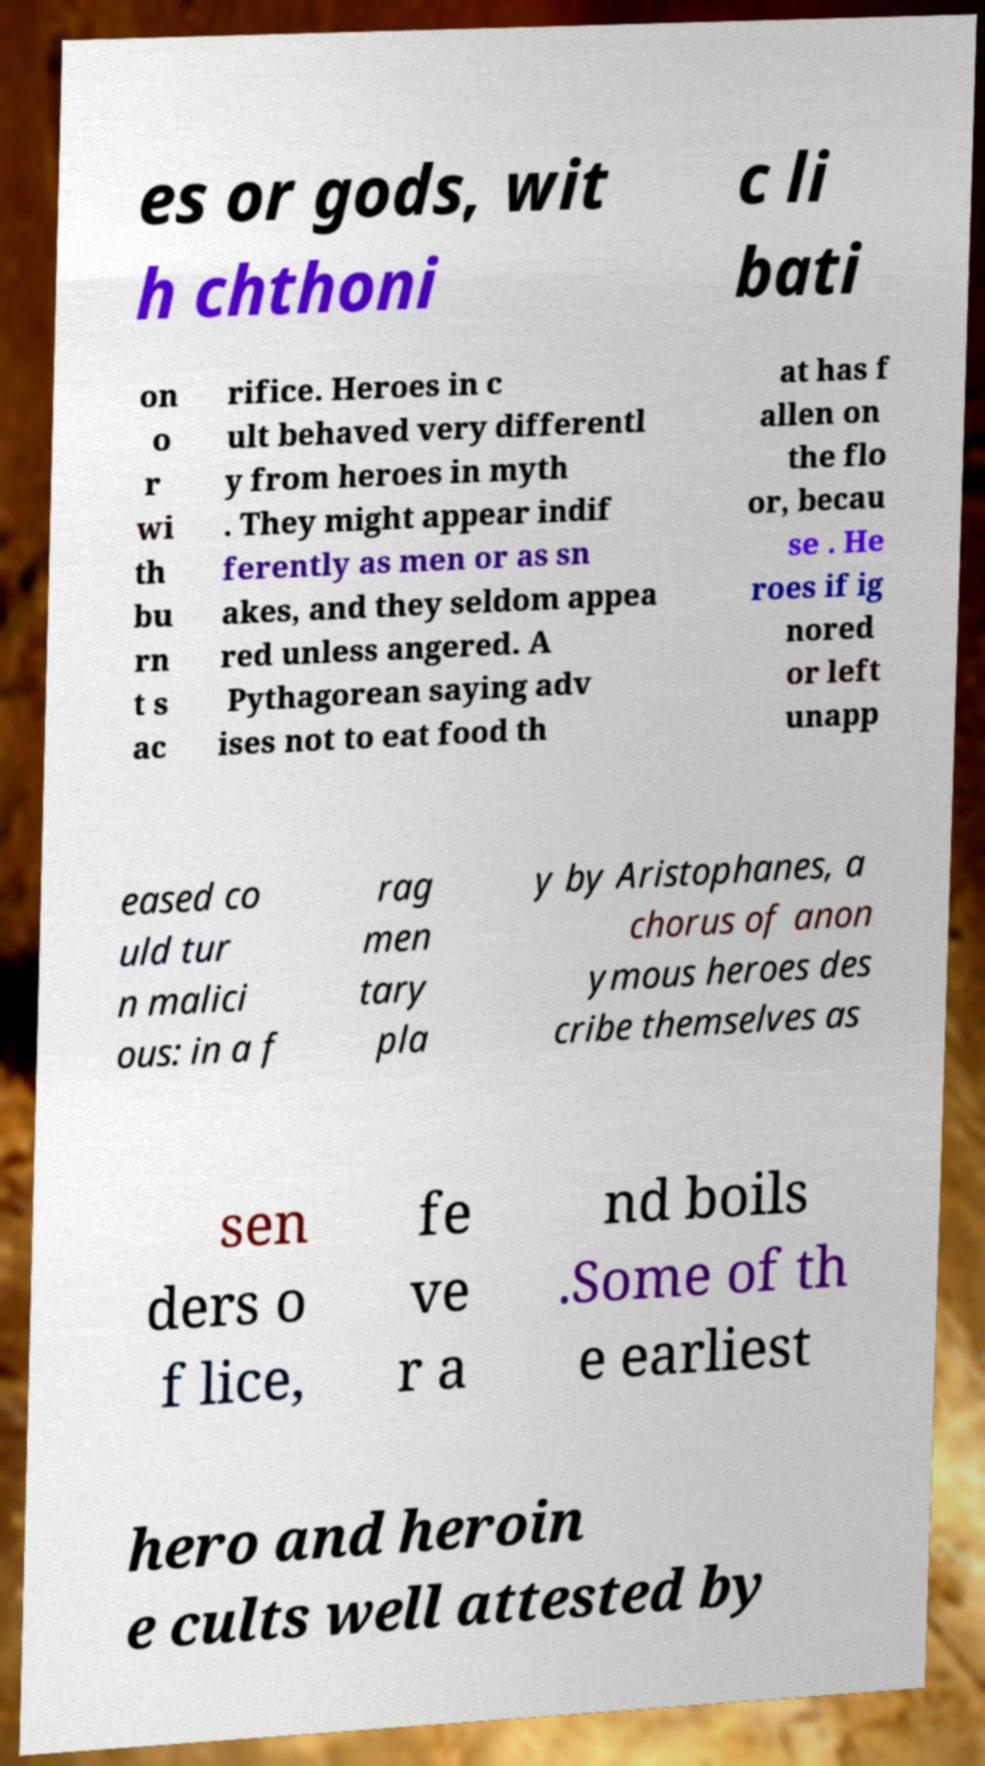Please identify and transcribe the text found in this image. es or gods, wit h chthoni c li bati on o r wi th bu rn t s ac rifice. Heroes in c ult behaved very differentl y from heroes in myth . They might appear indif ferently as men or as sn akes, and they seldom appea red unless angered. A Pythagorean saying adv ises not to eat food th at has f allen on the flo or, becau se . He roes if ig nored or left unapp eased co uld tur n malici ous: in a f rag men tary pla y by Aristophanes, a chorus of anon ymous heroes des cribe themselves as sen ders o f lice, fe ve r a nd boils .Some of th e earliest hero and heroin e cults well attested by 